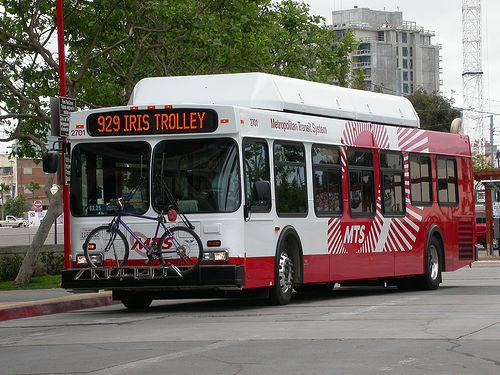What is placed in front of the bus?
Be succinct. Bike. What is the company name for the trolley?
Be succinct. Metropolitan transit system. What color is this bus?
Answer briefly. Red and white. What letters are on the bus?
Be succinct. Mts. 